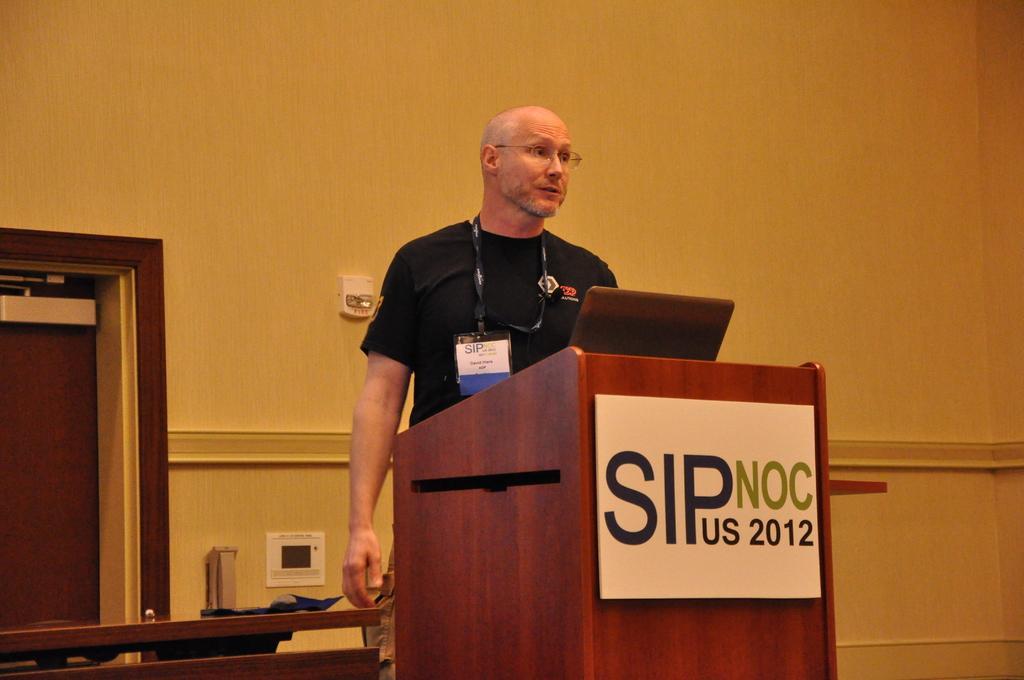Describe this image in one or two sentences. In the image we can see a man standing wearing clothes, spectacles and identity card. This is a podium, door, wall and other object, this is a poster. 